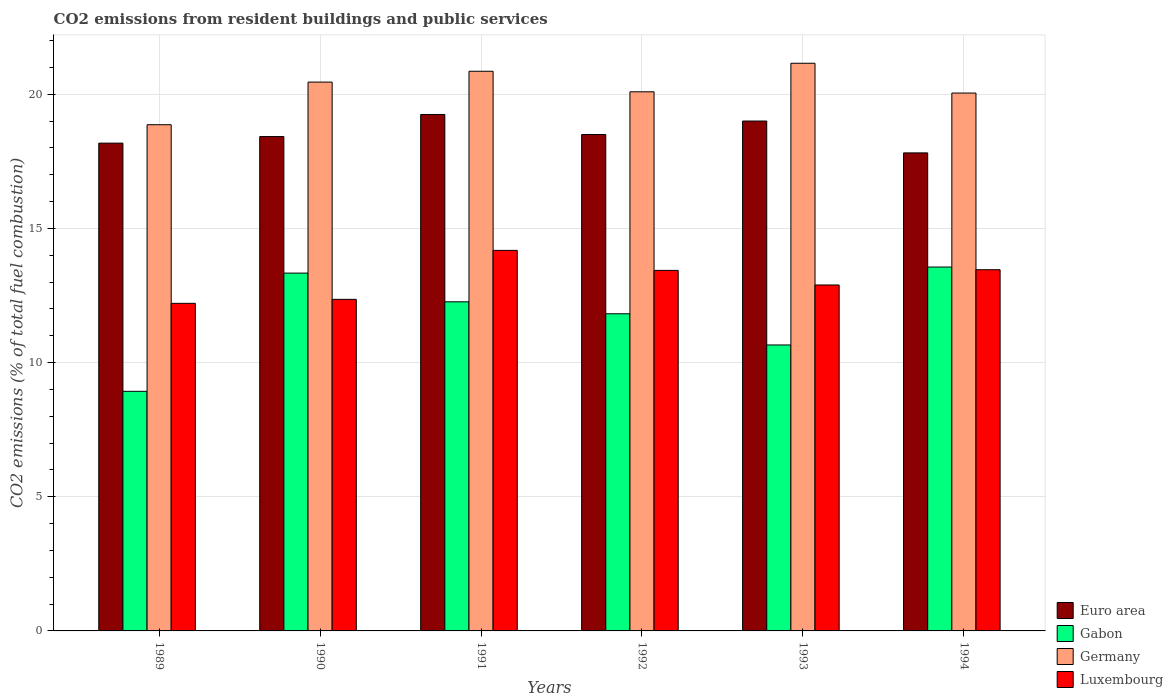Are the number of bars on each tick of the X-axis equal?
Ensure brevity in your answer.  Yes. How many bars are there on the 3rd tick from the left?
Offer a terse response. 4. What is the label of the 6th group of bars from the left?
Provide a short and direct response. 1994. In how many cases, is the number of bars for a given year not equal to the number of legend labels?
Your response must be concise. 0. What is the total CO2 emitted in Germany in 1992?
Your answer should be compact. 20.09. Across all years, what is the maximum total CO2 emitted in Euro area?
Give a very brief answer. 19.24. Across all years, what is the minimum total CO2 emitted in Euro area?
Make the answer very short. 17.81. In which year was the total CO2 emitted in Germany minimum?
Provide a succinct answer. 1989. What is the total total CO2 emitted in Germany in the graph?
Make the answer very short. 121.45. What is the difference between the total CO2 emitted in Germany in 1990 and that in 1994?
Give a very brief answer. 0.41. What is the difference between the total CO2 emitted in Euro area in 1989 and the total CO2 emitted in Germany in 1991?
Ensure brevity in your answer.  -2.68. What is the average total CO2 emitted in Gabon per year?
Keep it short and to the point. 11.76. In the year 1993, what is the difference between the total CO2 emitted in Luxembourg and total CO2 emitted in Gabon?
Keep it short and to the point. 2.24. In how many years, is the total CO2 emitted in Gabon greater than 18?
Ensure brevity in your answer.  0. What is the ratio of the total CO2 emitted in Germany in 1990 to that in 1993?
Your response must be concise. 0.97. Is the difference between the total CO2 emitted in Luxembourg in 1991 and 1992 greater than the difference between the total CO2 emitted in Gabon in 1991 and 1992?
Your answer should be compact. Yes. What is the difference between the highest and the second highest total CO2 emitted in Luxembourg?
Your answer should be compact. 0.72. What is the difference between the highest and the lowest total CO2 emitted in Euro area?
Your answer should be very brief. 1.43. Is the sum of the total CO2 emitted in Germany in 1992 and 1993 greater than the maximum total CO2 emitted in Euro area across all years?
Offer a very short reply. Yes. What does the 2nd bar from the left in 1991 represents?
Your response must be concise. Gabon. What does the 2nd bar from the right in 1990 represents?
Ensure brevity in your answer.  Germany. Is it the case that in every year, the sum of the total CO2 emitted in Germany and total CO2 emitted in Euro area is greater than the total CO2 emitted in Luxembourg?
Offer a very short reply. Yes. Are all the bars in the graph horizontal?
Keep it short and to the point. No. How many years are there in the graph?
Make the answer very short. 6. What is the difference between two consecutive major ticks on the Y-axis?
Make the answer very short. 5. Are the values on the major ticks of Y-axis written in scientific E-notation?
Provide a short and direct response. No. Where does the legend appear in the graph?
Your response must be concise. Bottom right. What is the title of the graph?
Offer a terse response. CO2 emissions from resident buildings and public services. What is the label or title of the X-axis?
Your answer should be very brief. Years. What is the label or title of the Y-axis?
Provide a succinct answer. CO2 emissions (% of total fuel combustion). What is the CO2 emissions (% of total fuel combustion) in Euro area in 1989?
Make the answer very short. 18.18. What is the CO2 emissions (% of total fuel combustion) of Gabon in 1989?
Offer a terse response. 8.93. What is the CO2 emissions (% of total fuel combustion) in Germany in 1989?
Your response must be concise. 18.86. What is the CO2 emissions (% of total fuel combustion) of Luxembourg in 1989?
Ensure brevity in your answer.  12.21. What is the CO2 emissions (% of total fuel combustion) in Euro area in 1990?
Give a very brief answer. 18.42. What is the CO2 emissions (% of total fuel combustion) in Gabon in 1990?
Offer a very short reply. 13.33. What is the CO2 emissions (% of total fuel combustion) of Germany in 1990?
Provide a short and direct response. 20.45. What is the CO2 emissions (% of total fuel combustion) of Luxembourg in 1990?
Keep it short and to the point. 12.36. What is the CO2 emissions (% of total fuel combustion) of Euro area in 1991?
Offer a terse response. 19.24. What is the CO2 emissions (% of total fuel combustion) of Gabon in 1991?
Provide a short and direct response. 12.26. What is the CO2 emissions (% of total fuel combustion) of Germany in 1991?
Ensure brevity in your answer.  20.85. What is the CO2 emissions (% of total fuel combustion) of Luxembourg in 1991?
Offer a very short reply. 14.18. What is the CO2 emissions (% of total fuel combustion) of Euro area in 1992?
Offer a terse response. 18.5. What is the CO2 emissions (% of total fuel combustion) of Gabon in 1992?
Give a very brief answer. 11.82. What is the CO2 emissions (% of total fuel combustion) of Germany in 1992?
Your answer should be compact. 20.09. What is the CO2 emissions (% of total fuel combustion) in Luxembourg in 1992?
Your answer should be compact. 13.43. What is the CO2 emissions (% of total fuel combustion) of Euro area in 1993?
Your answer should be very brief. 19. What is the CO2 emissions (% of total fuel combustion) in Gabon in 1993?
Your answer should be compact. 10.66. What is the CO2 emissions (% of total fuel combustion) of Germany in 1993?
Provide a succinct answer. 21.15. What is the CO2 emissions (% of total fuel combustion) in Luxembourg in 1993?
Provide a succinct answer. 12.89. What is the CO2 emissions (% of total fuel combustion) in Euro area in 1994?
Your answer should be compact. 17.81. What is the CO2 emissions (% of total fuel combustion) in Gabon in 1994?
Give a very brief answer. 13.56. What is the CO2 emissions (% of total fuel combustion) in Germany in 1994?
Provide a short and direct response. 20.04. What is the CO2 emissions (% of total fuel combustion) in Luxembourg in 1994?
Your answer should be very brief. 13.46. Across all years, what is the maximum CO2 emissions (% of total fuel combustion) in Euro area?
Provide a short and direct response. 19.24. Across all years, what is the maximum CO2 emissions (% of total fuel combustion) in Gabon?
Make the answer very short. 13.56. Across all years, what is the maximum CO2 emissions (% of total fuel combustion) in Germany?
Make the answer very short. 21.15. Across all years, what is the maximum CO2 emissions (% of total fuel combustion) in Luxembourg?
Provide a short and direct response. 14.18. Across all years, what is the minimum CO2 emissions (% of total fuel combustion) of Euro area?
Keep it short and to the point. 17.81. Across all years, what is the minimum CO2 emissions (% of total fuel combustion) of Gabon?
Provide a short and direct response. 8.93. Across all years, what is the minimum CO2 emissions (% of total fuel combustion) of Germany?
Give a very brief answer. 18.86. Across all years, what is the minimum CO2 emissions (% of total fuel combustion) in Luxembourg?
Keep it short and to the point. 12.21. What is the total CO2 emissions (% of total fuel combustion) in Euro area in the graph?
Provide a succinct answer. 111.15. What is the total CO2 emissions (% of total fuel combustion) in Gabon in the graph?
Offer a terse response. 70.56. What is the total CO2 emissions (% of total fuel combustion) of Germany in the graph?
Offer a terse response. 121.45. What is the total CO2 emissions (% of total fuel combustion) in Luxembourg in the graph?
Your answer should be very brief. 78.53. What is the difference between the CO2 emissions (% of total fuel combustion) of Euro area in 1989 and that in 1990?
Provide a succinct answer. -0.24. What is the difference between the CO2 emissions (% of total fuel combustion) of Gabon in 1989 and that in 1990?
Provide a succinct answer. -4.4. What is the difference between the CO2 emissions (% of total fuel combustion) in Germany in 1989 and that in 1990?
Your answer should be very brief. -1.59. What is the difference between the CO2 emissions (% of total fuel combustion) of Luxembourg in 1989 and that in 1990?
Give a very brief answer. -0.15. What is the difference between the CO2 emissions (% of total fuel combustion) of Euro area in 1989 and that in 1991?
Ensure brevity in your answer.  -1.07. What is the difference between the CO2 emissions (% of total fuel combustion) in Gabon in 1989 and that in 1991?
Your response must be concise. -3.34. What is the difference between the CO2 emissions (% of total fuel combustion) in Germany in 1989 and that in 1991?
Offer a terse response. -1.99. What is the difference between the CO2 emissions (% of total fuel combustion) of Luxembourg in 1989 and that in 1991?
Your answer should be very brief. -1.97. What is the difference between the CO2 emissions (% of total fuel combustion) in Euro area in 1989 and that in 1992?
Offer a terse response. -0.32. What is the difference between the CO2 emissions (% of total fuel combustion) of Gabon in 1989 and that in 1992?
Your answer should be very brief. -2.89. What is the difference between the CO2 emissions (% of total fuel combustion) of Germany in 1989 and that in 1992?
Provide a succinct answer. -1.23. What is the difference between the CO2 emissions (% of total fuel combustion) of Luxembourg in 1989 and that in 1992?
Give a very brief answer. -1.23. What is the difference between the CO2 emissions (% of total fuel combustion) of Euro area in 1989 and that in 1993?
Offer a very short reply. -0.82. What is the difference between the CO2 emissions (% of total fuel combustion) of Gabon in 1989 and that in 1993?
Your response must be concise. -1.73. What is the difference between the CO2 emissions (% of total fuel combustion) of Germany in 1989 and that in 1993?
Provide a short and direct response. -2.29. What is the difference between the CO2 emissions (% of total fuel combustion) of Luxembourg in 1989 and that in 1993?
Make the answer very short. -0.68. What is the difference between the CO2 emissions (% of total fuel combustion) of Euro area in 1989 and that in 1994?
Keep it short and to the point. 0.36. What is the difference between the CO2 emissions (% of total fuel combustion) in Gabon in 1989 and that in 1994?
Your answer should be very brief. -4.63. What is the difference between the CO2 emissions (% of total fuel combustion) in Germany in 1989 and that in 1994?
Your answer should be compact. -1.18. What is the difference between the CO2 emissions (% of total fuel combustion) of Luxembourg in 1989 and that in 1994?
Provide a succinct answer. -1.25. What is the difference between the CO2 emissions (% of total fuel combustion) in Euro area in 1990 and that in 1991?
Your answer should be compact. -0.82. What is the difference between the CO2 emissions (% of total fuel combustion) in Gabon in 1990 and that in 1991?
Your answer should be very brief. 1.07. What is the difference between the CO2 emissions (% of total fuel combustion) of Germany in 1990 and that in 1991?
Your answer should be compact. -0.4. What is the difference between the CO2 emissions (% of total fuel combustion) of Luxembourg in 1990 and that in 1991?
Your answer should be very brief. -1.83. What is the difference between the CO2 emissions (% of total fuel combustion) of Euro area in 1990 and that in 1992?
Offer a terse response. -0.08. What is the difference between the CO2 emissions (% of total fuel combustion) of Gabon in 1990 and that in 1992?
Keep it short and to the point. 1.52. What is the difference between the CO2 emissions (% of total fuel combustion) in Germany in 1990 and that in 1992?
Offer a terse response. 0.36. What is the difference between the CO2 emissions (% of total fuel combustion) in Luxembourg in 1990 and that in 1992?
Offer a very short reply. -1.08. What is the difference between the CO2 emissions (% of total fuel combustion) in Euro area in 1990 and that in 1993?
Offer a very short reply. -0.58. What is the difference between the CO2 emissions (% of total fuel combustion) in Gabon in 1990 and that in 1993?
Provide a succinct answer. 2.68. What is the difference between the CO2 emissions (% of total fuel combustion) of Germany in 1990 and that in 1993?
Ensure brevity in your answer.  -0.7. What is the difference between the CO2 emissions (% of total fuel combustion) in Luxembourg in 1990 and that in 1993?
Make the answer very short. -0.54. What is the difference between the CO2 emissions (% of total fuel combustion) in Euro area in 1990 and that in 1994?
Provide a succinct answer. 0.61. What is the difference between the CO2 emissions (% of total fuel combustion) in Gabon in 1990 and that in 1994?
Your answer should be compact. -0.23. What is the difference between the CO2 emissions (% of total fuel combustion) of Germany in 1990 and that in 1994?
Your response must be concise. 0.41. What is the difference between the CO2 emissions (% of total fuel combustion) in Luxembourg in 1990 and that in 1994?
Provide a succinct answer. -1.1. What is the difference between the CO2 emissions (% of total fuel combustion) in Euro area in 1991 and that in 1992?
Give a very brief answer. 0.75. What is the difference between the CO2 emissions (% of total fuel combustion) in Gabon in 1991 and that in 1992?
Offer a terse response. 0.45. What is the difference between the CO2 emissions (% of total fuel combustion) of Germany in 1991 and that in 1992?
Your response must be concise. 0.77. What is the difference between the CO2 emissions (% of total fuel combustion) of Luxembourg in 1991 and that in 1992?
Your answer should be very brief. 0.75. What is the difference between the CO2 emissions (% of total fuel combustion) in Euro area in 1991 and that in 1993?
Your answer should be compact. 0.24. What is the difference between the CO2 emissions (% of total fuel combustion) of Gabon in 1991 and that in 1993?
Ensure brevity in your answer.  1.61. What is the difference between the CO2 emissions (% of total fuel combustion) of Germany in 1991 and that in 1993?
Provide a short and direct response. -0.3. What is the difference between the CO2 emissions (% of total fuel combustion) in Luxembourg in 1991 and that in 1993?
Your response must be concise. 1.29. What is the difference between the CO2 emissions (% of total fuel combustion) of Euro area in 1991 and that in 1994?
Your answer should be very brief. 1.43. What is the difference between the CO2 emissions (% of total fuel combustion) of Gabon in 1991 and that in 1994?
Ensure brevity in your answer.  -1.3. What is the difference between the CO2 emissions (% of total fuel combustion) in Germany in 1991 and that in 1994?
Make the answer very short. 0.81. What is the difference between the CO2 emissions (% of total fuel combustion) of Luxembourg in 1991 and that in 1994?
Keep it short and to the point. 0.72. What is the difference between the CO2 emissions (% of total fuel combustion) in Euro area in 1992 and that in 1993?
Offer a very short reply. -0.5. What is the difference between the CO2 emissions (% of total fuel combustion) of Gabon in 1992 and that in 1993?
Provide a short and direct response. 1.16. What is the difference between the CO2 emissions (% of total fuel combustion) of Germany in 1992 and that in 1993?
Your response must be concise. -1.06. What is the difference between the CO2 emissions (% of total fuel combustion) of Luxembourg in 1992 and that in 1993?
Offer a terse response. 0.54. What is the difference between the CO2 emissions (% of total fuel combustion) of Euro area in 1992 and that in 1994?
Provide a short and direct response. 0.68. What is the difference between the CO2 emissions (% of total fuel combustion) of Gabon in 1992 and that in 1994?
Your answer should be very brief. -1.74. What is the difference between the CO2 emissions (% of total fuel combustion) of Germany in 1992 and that in 1994?
Provide a short and direct response. 0.05. What is the difference between the CO2 emissions (% of total fuel combustion) of Luxembourg in 1992 and that in 1994?
Ensure brevity in your answer.  -0.03. What is the difference between the CO2 emissions (% of total fuel combustion) of Euro area in 1993 and that in 1994?
Give a very brief answer. 1.19. What is the difference between the CO2 emissions (% of total fuel combustion) in Gabon in 1993 and that in 1994?
Provide a short and direct response. -2.9. What is the difference between the CO2 emissions (% of total fuel combustion) in Germany in 1993 and that in 1994?
Your answer should be compact. 1.11. What is the difference between the CO2 emissions (% of total fuel combustion) in Luxembourg in 1993 and that in 1994?
Your answer should be very brief. -0.57. What is the difference between the CO2 emissions (% of total fuel combustion) of Euro area in 1989 and the CO2 emissions (% of total fuel combustion) of Gabon in 1990?
Offer a very short reply. 4.84. What is the difference between the CO2 emissions (% of total fuel combustion) in Euro area in 1989 and the CO2 emissions (% of total fuel combustion) in Germany in 1990?
Make the answer very short. -2.27. What is the difference between the CO2 emissions (% of total fuel combustion) of Euro area in 1989 and the CO2 emissions (% of total fuel combustion) of Luxembourg in 1990?
Ensure brevity in your answer.  5.82. What is the difference between the CO2 emissions (% of total fuel combustion) of Gabon in 1989 and the CO2 emissions (% of total fuel combustion) of Germany in 1990?
Keep it short and to the point. -11.52. What is the difference between the CO2 emissions (% of total fuel combustion) of Gabon in 1989 and the CO2 emissions (% of total fuel combustion) of Luxembourg in 1990?
Make the answer very short. -3.43. What is the difference between the CO2 emissions (% of total fuel combustion) of Germany in 1989 and the CO2 emissions (% of total fuel combustion) of Luxembourg in 1990?
Provide a short and direct response. 6.51. What is the difference between the CO2 emissions (% of total fuel combustion) in Euro area in 1989 and the CO2 emissions (% of total fuel combustion) in Gabon in 1991?
Provide a succinct answer. 5.91. What is the difference between the CO2 emissions (% of total fuel combustion) in Euro area in 1989 and the CO2 emissions (% of total fuel combustion) in Germany in 1991?
Offer a terse response. -2.68. What is the difference between the CO2 emissions (% of total fuel combustion) in Euro area in 1989 and the CO2 emissions (% of total fuel combustion) in Luxembourg in 1991?
Provide a succinct answer. 4. What is the difference between the CO2 emissions (% of total fuel combustion) of Gabon in 1989 and the CO2 emissions (% of total fuel combustion) of Germany in 1991?
Your answer should be compact. -11.93. What is the difference between the CO2 emissions (% of total fuel combustion) in Gabon in 1989 and the CO2 emissions (% of total fuel combustion) in Luxembourg in 1991?
Keep it short and to the point. -5.25. What is the difference between the CO2 emissions (% of total fuel combustion) in Germany in 1989 and the CO2 emissions (% of total fuel combustion) in Luxembourg in 1991?
Your response must be concise. 4.68. What is the difference between the CO2 emissions (% of total fuel combustion) of Euro area in 1989 and the CO2 emissions (% of total fuel combustion) of Gabon in 1992?
Offer a very short reply. 6.36. What is the difference between the CO2 emissions (% of total fuel combustion) in Euro area in 1989 and the CO2 emissions (% of total fuel combustion) in Germany in 1992?
Make the answer very short. -1.91. What is the difference between the CO2 emissions (% of total fuel combustion) of Euro area in 1989 and the CO2 emissions (% of total fuel combustion) of Luxembourg in 1992?
Keep it short and to the point. 4.74. What is the difference between the CO2 emissions (% of total fuel combustion) of Gabon in 1989 and the CO2 emissions (% of total fuel combustion) of Germany in 1992?
Ensure brevity in your answer.  -11.16. What is the difference between the CO2 emissions (% of total fuel combustion) of Gabon in 1989 and the CO2 emissions (% of total fuel combustion) of Luxembourg in 1992?
Provide a succinct answer. -4.51. What is the difference between the CO2 emissions (% of total fuel combustion) in Germany in 1989 and the CO2 emissions (% of total fuel combustion) in Luxembourg in 1992?
Provide a short and direct response. 5.43. What is the difference between the CO2 emissions (% of total fuel combustion) in Euro area in 1989 and the CO2 emissions (% of total fuel combustion) in Gabon in 1993?
Ensure brevity in your answer.  7.52. What is the difference between the CO2 emissions (% of total fuel combustion) in Euro area in 1989 and the CO2 emissions (% of total fuel combustion) in Germany in 1993?
Your answer should be compact. -2.98. What is the difference between the CO2 emissions (% of total fuel combustion) in Euro area in 1989 and the CO2 emissions (% of total fuel combustion) in Luxembourg in 1993?
Make the answer very short. 5.29. What is the difference between the CO2 emissions (% of total fuel combustion) in Gabon in 1989 and the CO2 emissions (% of total fuel combustion) in Germany in 1993?
Provide a short and direct response. -12.22. What is the difference between the CO2 emissions (% of total fuel combustion) of Gabon in 1989 and the CO2 emissions (% of total fuel combustion) of Luxembourg in 1993?
Your answer should be compact. -3.96. What is the difference between the CO2 emissions (% of total fuel combustion) of Germany in 1989 and the CO2 emissions (% of total fuel combustion) of Luxembourg in 1993?
Keep it short and to the point. 5.97. What is the difference between the CO2 emissions (% of total fuel combustion) of Euro area in 1989 and the CO2 emissions (% of total fuel combustion) of Gabon in 1994?
Offer a very short reply. 4.62. What is the difference between the CO2 emissions (% of total fuel combustion) in Euro area in 1989 and the CO2 emissions (% of total fuel combustion) in Germany in 1994?
Provide a succinct answer. -1.87. What is the difference between the CO2 emissions (% of total fuel combustion) in Euro area in 1989 and the CO2 emissions (% of total fuel combustion) in Luxembourg in 1994?
Your answer should be compact. 4.72. What is the difference between the CO2 emissions (% of total fuel combustion) in Gabon in 1989 and the CO2 emissions (% of total fuel combustion) in Germany in 1994?
Make the answer very short. -11.11. What is the difference between the CO2 emissions (% of total fuel combustion) of Gabon in 1989 and the CO2 emissions (% of total fuel combustion) of Luxembourg in 1994?
Your response must be concise. -4.53. What is the difference between the CO2 emissions (% of total fuel combustion) in Germany in 1989 and the CO2 emissions (% of total fuel combustion) in Luxembourg in 1994?
Your answer should be compact. 5.4. What is the difference between the CO2 emissions (% of total fuel combustion) of Euro area in 1990 and the CO2 emissions (% of total fuel combustion) of Gabon in 1991?
Your answer should be compact. 6.16. What is the difference between the CO2 emissions (% of total fuel combustion) of Euro area in 1990 and the CO2 emissions (% of total fuel combustion) of Germany in 1991?
Your answer should be compact. -2.43. What is the difference between the CO2 emissions (% of total fuel combustion) in Euro area in 1990 and the CO2 emissions (% of total fuel combustion) in Luxembourg in 1991?
Your response must be concise. 4.24. What is the difference between the CO2 emissions (% of total fuel combustion) in Gabon in 1990 and the CO2 emissions (% of total fuel combustion) in Germany in 1991?
Make the answer very short. -7.52. What is the difference between the CO2 emissions (% of total fuel combustion) of Gabon in 1990 and the CO2 emissions (% of total fuel combustion) of Luxembourg in 1991?
Make the answer very short. -0.85. What is the difference between the CO2 emissions (% of total fuel combustion) of Germany in 1990 and the CO2 emissions (% of total fuel combustion) of Luxembourg in 1991?
Your response must be concise. 6.27. What is the difference between the CO2 emissions (% of total fuel combustion) of Euro area in 1990 and the CO2 emissions (% of total fuel combustion) of Gabon in 1992?
Provide a succinct answer. 6.6. What is the difference between the CO2 emissions (% of total fuel combustion) of Euro area in 1990 and the CO2 emissions (% of total fuel combustion) of Germany in 1992?
Your answer should be very brief. -1.67. What is the difference between the CO2 emissions (% of total fuel combustion) of Euro area in 1990 and the CO2 emissions (% of total fuel combustion) of Luxembourg in 1992?
Give a very brief answer. 4.99. What is the difference between the CO2 emissions (% of total fuel combustion) of Gabon in 1990 and the CO2 emissions (% of total fuel combustion) of Germany in 1992?
Ensure brevity in your answer.  -6.76. What is the difference between the CO2 emissions (% of total fuel combustion) in Gabon in 1990 and the CO2 emissions (% of total fuel combustion) in Luxembourg in 1992?
Keep it short and to the point. -0.1. What is the difference between the CO2 emissions (% of total fuel combustion) of Germany in 1990 and the CO2 emissions (% of total fuel combustion) of Luxembourg in 1992?
Ensure brevity in your answer.  7.02. What is the difference between the CO2 emissions (% of total fuel combustion) of Euro area in 1990 and the CO2 emissions (% of total fuel combustion) of Gabon in 1993?
Provide a succinct answer. 7.77. What is the difference between the CO2 emissions (% of total fuel combustion) in Euro area in 1990 and the CO2 emissions (% of total fuel combustion) in Germany in 1993?
Make the answer very short. -2.73. What is the difference between the CO2 emissions (% of total fuel combustion) of Euro area in 1990 and the CO2 emissions (% of total fuel combustion) of Luxembourg in 1993?
Your response must be concise. 5.53. What is the difference between the CO2 emissions (% of total fuel combustion) in Gabon in 1990 and the CO2 emissions (% of total fuel combustion) in Germany in 1993?
Provide a succinct answer. -7.82. What is the difference between the CO2 emissions (% of total fuel combustion) in Gabon in 1990 and the CO2 emissions (% of total fuel combustion) in Luxembourg in 1993?
Your response must be concise. 0.44. What is the difference between the CO2 emissions (% of total fuel combustion) in Germany in 1990 and the CO2 emissions (% of total fuel combustion) in Luxembourg in 1993?
Keep it short and to the point. 7.56. What is the difference between the CO2 emissions (% of total fuel combustion) in Euro area in 1990 and the CO2 emissions (% of total fuel combustion) in Gabon in 1994?
Your response must be concise. 4.86. What is the difference between the CO2 emissions (% of total fuel combustion) in Euro area in 1990 and the CO2 emissions (% of total fuel combustion) in Germany in 1994?
Provide a short and direct response. -1.62. What is the difference between the CO2 emissions (% of total fuel combustion) of Euro area in 1990 and the CO2 emissions (% of total fuel combustion) of Luxembourg in 1994?
Your answer should be very brief. 4.96. What is the difference between the CO2 emissions (% of total fuel combustion) in Gabon in 1990 and the CO2 emissions (% of total fuel combustion) in Germany in 1994?
Your answer should be compact. -6.71. What is the difference between the CO2 emissions (% of total fuel combustion) in Gabon in 1990 and the CO2 emissions (% of total fuel combustion) in Luxembourg in 1994?
Your response must be concise. -0.13. What is the difference between the CO2 emissions (% of total fuel combustion) of Germany in 1990 and the CO2 emissions (% of total fuel combustion) of Luxembourg in 1994?
Your answer should be compact. 6.99. What is the difference between the CO2 emissions (% of total fuel combustion) of Euro area in 1991 and the CO2 emissions (% of total fuel combustion) of Gabon in 1992?
Provide a succinct answer. 7.43. What is the difference between the CO2 emissions (% of total fuel combustion) of Euro area in 1991 and the CO2 emissions (% of total fuel combustion) of Germany in 1992?
Provide a succinct answer. -0.85. What is the difference between the CO2 emissions (% of total fuel combustion) in Euro area in 1991 and the CO2 emissions (% of total fuel combustion) in Luxembourg in 1992?
Give a very brief answer. 5.81. What is the difference between the CO2 emissions (% of total fuel combustion) in Gabon in 1991 and the CO2 emissions (% of total fuel combustion) in Germany in 1992?
Your response must be concise. -7.83. What is the difference between the CO2 emissions (% of total fuel combustion) in Gabon in 1991 and the CO2 emissions (% of total fuel combustion) in Luxembourg in 1992?
Make the answer very short. -1.17. What is the difference between the CO2 emissions (% of total fuel combustion) of Germany in 1991 and the CO2 emissions (% of total fuel combustion) of Luxembourg in 1992?
Offer a very short reply. 7.42. What is the difference between the CO2 emissions (% of total fuel combustion) in Euro area in 1991 and the CO2 emissions (% of total fuel combustion) in Gabon in 1993?
Your answer should be very brief. 8.59. What is the difference between the CO2 emissions (% of total fuel combustion) of Euro area in 1991 and the CO2 emissions (% of total fuel combustion) of Germany in 1993?
Give a very brief answer. -1.91. What is the difference between the CO2 emissions (% of total fuel combustion) in Euro area in 1991 and the CO2 emissions (% of total fuel combustion) in Luxembourg in 1993?
Your response must be concise. 6.35. What is the difference between the CO2 emissions (% of total fuel combustion) of Gabon in 1991 and the CO2 emissions (% of total fuel combustion) of Germany in 1993?
Your response must be concise. -8.89. What is the difference between the CO2 emissions (% of total fuel combustion) of Gabon in 1991 and the CO2 emissions (% of total fuel combustion) of Luxembourg in 1993?
Provide a succinct answer. -0.63. What is the difference between the CO2 emissions (% of total fuel combustion) in Germany in 1991 and the CO2 emissions (% of total fuel combustion) in Luxembourg in 1993?
Provide a short and direct response. 7.96. What is the difference between the CO2 emissions (% of total fuel combustion) of Euro area in 1991 and the CO2 emissions (% of total fuel combustion) of Gabon in 1994?
Ensure brevity in your answer.  5.69. What is the difference between the CO2 emissions (% of total fuel combustion) in Euro area in 1991 and the CO2 emissions (% of total fuel combustion) in Germany in 1994?
Make the answer very short. -0.8. What is the difference between the CO2 emissions (% of total fuel combustion) of Euro area in 1991 and the CO2 emissions (% of total fuel combustion) of Luxembourg in 1994?
Provide a succinct answer. 5.78. What is the difference between the CO2 emissions (% of total fuel combustion) in Gabon in 1991 and the CO2 emissions (% of total fuel combustion) in Germany in 1994?
Provide a short and direct response. -7.78. What is the difference between the CO2 emissions (% of total fuel combustion) of Gabon in 1991 and the CO2 emissions (% of total fuel combustion) of Luxembourg in 1994?
Provide a succinct answer. -1.2. What is the difference between the CO2 emissions (% of total fuel combustion) in Germany in 1991 and the CO2 emissions (% of total fuel combustion) in Luxembourg in 1994?
Give a very brief answer. 7.4. What is the difference between the CO2 emissions (% of total fuel combustion) in Euro area in 1992 and the CO2 emissions (% of total fuel combustion) in Gabon in 1993?
Give a very brief answer. 7.84. What is the difference between the CO2 emissions (% of total fuel combustion) in Euro area in 1992 and the CO2 emissions (% of total fuel combustion) in Germany in 1993?
Offer a very short reply. -2.66. What is the difference between the CO2 emissions (% of total fuel combustion) of Euro area in 1992 and the CO2 emissions (% of total fuel combustion) of Luxembourg in 1993?
Give a very brief answer. 5.61. What is the difference between the CO2 emissions (% of total fuel combustion) of Gabon in 1992 and the CO2 emissions (% of total fuel combustion) of Germany in 1993?
Your answer should be compact. -9.33. What is the difference between the CO2 emissions (% of total fuel combustion) in Gabon in 1992 and the CO2 emissions (% of total fuel combustion) in Luxembourg in 1993?
Your response must be concise. -1.07. What is the difference between the CO2 emissions (% of total fuel combustion) of Germany in 1992 and the CO2 emissions (% of total fuel combustion) of Luxembourg in 1993?
Give a very brief answer. 7.2. What is the difference between the CO2 emissions (% of total fuel combustion) of Euro area in 1992 and the CO2 emissions (% of total fuel combustion) of Gabon in 1994?
Your answer should be very brief. 4.94. What is the difference between the CO2 emissions (% of total fuel combustion) of Euro area in 1992 and the CO2 emissions (% of total fuel combustion) of Germany in 1994?
Give a very brief answer. -1.55. What is the difference between the CO2 emissions (% of total fuel combustion) in Euro area in 1992 and the CO2 emissions (% of total fuel combustion) in Luxembourg in 1994?
Offer a terse response. 5.04. What is the difference between the CO2 emissions (% of total fuel combustion) of Gabon in 1992 and the CO2 emissions (% of total fuel combustion) of Germany in 1994?
Your answer should be very brief. -8.22. What is the difference between the CO2 emissions (% of total fuel combustion) in Gabon in 1992 and the CO2 emissions (% of total fuel combustion) in Luxembourg in 1994?
Keep it short and to the point. -1.64. What is the difference between the CO2 emissions (% of total fuel combustion) of Germany in 1992 and the CO2 emissions (% of total fuel combustion) of Luxembourg in 1994?
Offer a terse response. 6.63. What is the difference between the CO2 emissions (% of total fuel combustion) of Euro area in 1993 and the CO2 emissions (% of total fuel combustion) of Gabon in 1994?
Provide a succinct answer. 5.44. What is the difference between the CO2 emissions (% of total fuel combustion) in Euro area in 1993 and the CO2 emissions (% of total fuel combustion) in Germany in 1994?
Keep it short and to the point. -1.04. What is the difference between the CO2 emissions (% of total fuel combustion) in Euro area in 1993 and the CO2 emissions (% of total fuel combustion) in Luxembourg in 1994?
Ensure brevity in your answer.  5.54. What is the difference between the CO2 emissions (% of total fuel combustion) in Gabon in 1993 and the CO2 emissions (% of total fuel combustion) in Germany in 1994?
Ensure brevity in your answer.  -9.39. What is the difference between the CO2 emissions (% of total fuel combustion) in Gabon in 1993 and the CO2 emissions (% of total fuel combustion) in Luxembourg in 1994?
Offer a terse response. -2.8. What is the difference between the CO2 emissions (% of total fuel combustion) of Germany in 1993 and the CO2 emissions (% of total fuel combustion) of Luxembourg in 1994?
Your answer should be compact. 7.69. What is the average CO2 emissions (% of total fuel combustion) of Euro area per year?
Provide a short and direct response. 18.53. What is the average CO2 emissions (% of total fuel combustion) of Gabon per year?
Offer a terse response. 11.76. What is the average CO2 emissions (% of total fuel combustion) in Germany per year?
Provide a short and direct response. 20.24. What is the average CO2 emissions (% of total fuel combustion) of Luxembourg per year?
Keep it short and to the point. 13.09. In the year 1989, what is the difference between the CO2 emissions (% of total fuel combustion) in Euro area and CO2 emissions (% of total fuel combustion) in Gabon?
Give a very brief answer. 9.25. In the year 1989, what is the difference between the CO2 emissions (% of total fuel combustion) of Euro area and CO2 emissions (% of total fuel combustion) of Germany?
Ensure brevity in your answer.  -0.69. In the year 1989, what is the difference between the CO2 emissions (% of total fuel combustion) in Euro area and CO2 emissions (% of total fuel combustion) in Luxembourg?
Provide a short and direct response. 5.97. In the year 1989, what is the difference between the CO2 emissions (% of total fuel combustion) of Gabon and CO2 emissions (% of total fuel combustion) of Germany?
Provide a short and direct response. -9.93. In the year 1989, what is the difference between the CO2 emissions (% of total fuel combustion) in Gabon and CO2 emissions (% of total fuel combustion) in Luxembourg?
Provide a short and direct response. -3.28. In the year 1989, what is the difference between the CO2 emissions (% of total fuel combustion) of Germany and CO2 emissions (% of total fuel combustion) of Luxembourg?
Give a very brief answer. 6.66. In the year 1990, what is the difference between the CO2 emissions (% of total fuel combustion) of Euro area and CO2 emissions (% of total fuel combustion) of Gabon?
Provide a succinct answer. 5.09. In the year 1990, what is the difference between the CO2 emissions (% of total fuel combustion) of Euro area and CO2 emissions (% of total fuel combustion) of Germany?
Offer a terse response. -2.03. In the year 1990, what is the difference between the CO2 emissions (% of total fuel combustion) in Euro area and CO2 emissions (% of total fuel combustion) in Luxembourg?
Ensure brevity in your answer.  6.07. In the year 1990, what is the difference between the CO2 emissions (% of total fuel combustion) of Gabon and CO2 emissions (% of total fuel combustion) of Germany?
Keep it short and to the point. -7.12. In the year 1990, what is the difference between the CO2 emissions (% of total fuel combustion) of Gabon and CO2 emissions (% of total fuel combustion) of Luxembourg?
Make the answer very short. 0.98. In the year 1990, what is the difference between the CO2 emissions (% of total fuel combustion) of Germany and CO2 emissions (% of total fuel combustion) of Luxembourg?
Offer a terse response. 8.1. In the year 1991, what is the difference between the CO2 emissions (% of total fuel combustion) of Euro area and CO2 emissions (% of total fuel combustion) of Gabon?
Give a very brief answer. 6.98. In the year 1991, what is the difference between the CO2 emissions (% of total fuel combustion) in Euro area and CO2 emissions (% of total fuel combustion) in Germany?
Offer a very short reply. -1.61. In the year 1991, what is the difference between the CO2 emissions (% of total fuel combustion) of Euro area and CO2 emissions (% of total fuel combustion) of Luxembourg?
Make the answer very short. 5.06. In the year 1991, what is the difference between the CO2 emissions (% of total fuel combustion) in Gabon and CO2 emissions (% of total fuel combustion) in Germany?
Offer a very short reply. -8.59. In the year 1991, what is the difference between the CO2 emissions (% of total fuel combustion) of Gabon and CO2 emissions (% of total fuel combustion) of Luxembourg?
Provide a short and direct response. -1.92. In the year 1991, what is the difference between the CO2 emissions (% of total fuel combustion) in Germany and CO2 emissions (% of total fuel combustion) in Luxembourg?
Your response must be concise. 6.67. In the year 1992, what is the difference between the CO2 emissions (% of total fuel combustion) of Euro area and CO2 emissions (% of total fuel combustion) of Gabon?
Your answer should be very brief. 6.68. In the year 1992, what is the difference between the CO2 emissions (% of total fuel combustion) in Euro area and CO2 emissions (% of total fuel combustion) in Germany?
Make the answer very short. -1.59. In the year 1992, what is the difference between the CO2 emissions (% of total fuel combustion) of Euro area and CO2 emissions (% of total fuel combustion) of Luxembourg?
Provide a short and direct response. 5.06. In the year 1992, what is the difference between the CO2 emissions (% of total fuel combustion) in Gabon and CO2 emissions (% of total fuel combustion) in Germany?
Offer a terse response. -8.27. In the year 1992, what is the difference between the CO2 emissions (% of total fuel combustion) in Gabon and CO2 emissions (% of total fuel combustion) in Luxembourg?
Offer a very short reply. -1.62. In the year 1992, what is the difference between the CO2 emissions (% of total fuel combustion) in Germany and CO2 emissions (% of total fuel combustion) in Luxembourg?
Make the answer very short. 6.66. In the year 1993, what is the difference between the CO2 emissions (% of total fuel combustion) of Euro area and CO2 emissions (% of total fuel combustion) of Gabon?
Your answer should be compact. 8.34. In the year 1993, what is the difference between the CO2 emissions (% of total fuel combustion) of Euro area and CO2 emissions (% of total fuel combustion) of Germany?
Offer a terse response. -2.15. In the year 1993, what is the difference between the CO2 emissions (% of total fuel combustion) of Euro area and CO2 emissions (% of total fuel combustion) of Luxembourg?
Your answer should be compact. 6.11. In the year 1993, what is the difference between the CO2 emissions (% of total fuel combustion) in Gabon and CO2 emissions (% of total fuel combustion) in Germany?
Provide a short and direct response. -10.5. In the year 1993, what is the difference between the CO2 emissions (% of total fuel combustion) in Gabon and CO2 emissions (% of total fuel combustion) in Luxembourg?
Give a very brief answer. -2.24. In the year 1993, what is the difference between the CO2 emissions (% of total fuel combustion) in Germany and CO2 emissions (% of total fuel combustion) in Luxembourg?
Provide a succinct answer. 8.26. In the year 1994, what is the difference between the CO2 emissions (% of total fuel combustion) of Euro area and CO2 emissions (% of total fuel combustion) of Gabon?
Offer a very short reply. 4.25. In the year 1994, what is the difference between the CO2 emissions (% of total fuel combustion) in Euro area and CO2 emissions (% of total fuel combustion) in Germany?
Provide a succinct answer. -2.23. In the year 1994, what is the difference between the CO2 emissions (% of total fuel combustion) in Euro area and CO2 emissions (% of total fuel combustion) in Luxembourg?
Provide a short and direct response. 4.35. In the year 1994, what is the difference between the CO2 emissions (% of total fuel combustion) of Gabon and CO2 emissions (% of total fuel combustion) of Germany?
Offer a terse response. -6.48. In the year 1994, what is the difference between the CO2 emissions (% of total fuel combustion) in Gabon and CO2 emissions (% of total fuel combustion) in Luxembourg?
Your answer should be very brief. 0.1. In the year 1994, what is the difference between the CO2 emissions (% of total fuel combustion) of Germany and CO2 emissions (% of total fuel combustion) of Luxembourg?
Ensure brevity in your answer.  6.58. What is the ratio of the CO2 emissions (% of total fuel combustion) of Euro area in 1989 to that in 1990?
Make the answer very short. 0.99. What is the ratio of the CO2 emissions (% of total fuel combustion) in Gabon in 1989 to that in 1990?
Your answer should be very brief. 0.67. What is the ratio of the CO2 emissions (% of total fuel combustion) of Germany in 1989 to that in 1990?
Ensure brevity in your answer.  0.92. What is the ratio of the CO2 emissions (% of total fuel combustion) in Luxembourg in 1989 to that in 1990?
Make the answer very short. 0.99. What is the ratio of the CO2 emissions (% of total fuel combustion) of Euro area in 1989 to that in 1991?
Your answer should be very brief. 0.94. What is the ratio of the CO2 emissions (% of total fuel combustion) of Gabon in 1989 to that in 1991?
Give a very brief answer. 0.73. What is the ratio of the CO2 emissions (% of total fuel combustion) of Germany in 1989 to that in 1991?
Ensure brevity in your answer.  0.9. What is the ratio of the CO2 emissions (% of total fuel combustion) in Luxembourg in 1989 to that in 1991?
Your response must be concise. 0.86. What is the ratio of the CO2 emissions (% of total fuel combustion) in Euro area in 1989 to that in 1992?
Provide a short and direct response. 0.98. What is the ratio of the CO2 emissions (% of total fuel combustion) of Gabon in 1989 to that in 1992?
Give a very brief answer. 0.76. What is the ratio of the CO2 emissions (% of total fuel combustion) in Germany in 1989 to that in 1992?
Ensure brevity in your answer.  0.94. What is the ratio of the CO2 emissions (% of total fuel combustion) in Luxembourg in 1989 to that in 1992?
Ensure brevity in your answer.  0.91. What is the ratio of the CO2 emissions (% of total fuel combustion) of Euro area in 1989 to that in 1993?
Give a very brief answer. 0.96. What is the ratio of the CO2 emissions (% of total fuel combustion) of Gabon in 1989 to that in 1993?
Your response must be concise. 0.84. What is the ratio of the CO2 emissions (% of total fuel combustion) of Germany in 1989 to that in 1993?
Your answer should be compact. 0.89. What is the ratio of the CO2 emissions (% of total fuel combustion) of Luxembourg in 1989 to that in 1993?
Your answer should be compact. 0.95. What is the ratio of the CO2 emissions (% of total fuel combustion) of Euro area in 1989 to that in 1994?
Your answer should be compact. 1.02. What is the ratio of the CO2 emissions (% of total fuel combustion) in Gabon in 1989 to that in 1994?
Your answer should be compact. 0.66. What is the ratio of the CO2 emissions (% of total fuel combustion) of Germany in 1989 to that in 1994?
Make the answer very short. 0.94. What is the ratio of the CO2 emissions (% of total fuel combustion) of Luxembourg in 1989 to that in 1994?
Provide a short and direct response. 0.91. What is the ratio of the CO2 emissions (% of total fuel combustion) in Euro area in 1990 to that in 1991?
Offer a very short reply. 0.96. What is the ratio of the CO2 emissions (% of total fuel combustion) of Gabon in 1990 to that in 1991?
Your answer should be very brief. 1.09. What is the ratio of the CO2 emissions (% of total fuel combustion) in Germany in 1990 to that in 1991?
Provide a short and direct response. 0.98. What is the ratio of the CO2 emissions (% of total fuel combustion) in Luxembourg in 1990 to that in 1991?
Provide a succinct answer. 0.87. What is the ratio of the CO2 emissions (% of total fuel combustion) in Euro area in 1990 to that in 1992?
Give a very brief answer. 1. What is the ratio of the CO2 emissions (% of total fuel combustion) of Gabon in 1990 to that in 1992?
Your response must be concise. 1.13. What is the ratio of the CO2 emissions (% of total fuel combustion) of Germany in 1990 to that in 1992?
Keep it short and to the point. 1.02. What is the ratio of the CO2 emissions (% of total fuel combustion) in Luxembourg in 1990 to that in 1992?
Your answer should be very brief. 0.92. What is the ratio of the CO2 emissions (% of total fuel combustion) in Euro area in 1990 to that in 1993?
Your response must be concise. 0.97. What is the ratio of the CO2 emissions (% of total fuel combustion) of Gabon in 1990 to that in 1993?
Make the answer very short. 1.25. What is the ratio of the CO2 emissions (% of total fuel combustion) in Germany in 1990 to that in 1993?
Offer a very short reply. 0.97. What is the ratio of the CO2 emissions (% of total fuel combustion) of Luxembourg in 1990 to that in 1993?
Give a very brief answer. 0.96. What is the ratio of the CO2 emissions (% of total fuel combustion) of Euro area in 1990 to that in 1994?
Your answer should be compact. 1.03. What is the ratio of the CO2 emissions (% of total fuel combustion) in Gabon in 1990 to that in 1994?
Your answer should be very brief. 0.98. What is the ratio of the CO2 emissions (% of total fuel combustion) in Germany in 1990 to that in 1994?
Keep it short and to the point. 1.02. What is the ratio of the CO2 emissions (% of total fuel combustion) of Luxembourg in 1990 to that in 1994?
Offer a terse response. 0.92. What is the ratio of the CO2 emissions (% of total fuel combustion) of Euro area in 1991 to that in 1992?
Make the answer very short. 1.04. What is the ratio of the CO2 emissions (% of total fuel combustion) of Gabon in 1991 to that in 1992?
Offer a terse response. 1.04. What is the ratio of the CO2 emissions (% of total fuel combustion) in Germany in 1991 to that in 1992?
Provide a succinct answer. 1.04. What is the ratio of the CO2 emissions (% of total fuel combustion) of Luxembourg in 1991 to that in 1992?
Offer a terse response. 1.06. What is the ratio of the CO2 emissions (% of total fuel combustion) in Euro area in 1991 to that in 1993?
Make the answer very short. 1.01. What is the ratio of the CO2 emissions (% of total fuel combustion) in Gabon in 1991 to that in 1993?
Your response must be concise. 1.15. What is the ratio of the CO2 emissions (% of total fuel combustion) of Germany in 1991 to that in 1993?
Provide a short and direct response. 0.99. What is the ratio of the CO2 emissions (% of total fuel combustion) of Luxembourg in 1991 to that in 1993?
Give a very brief answer. 1.1. What is the ratio of the CO2 emissions (% of total fuel combustion) in Euro area in 1991 to that in 1994?
Your answer should be compact. 1.08. What is the ratio of the CO2 emissions (% of total fuel combustion) in Gabon in 1991 to that in 1994?
Provide a succinct answer. 0.9. What is the ratio of the CO2 emissions (% of total fuel combustion) of Germany in 1991 to that in 1994?
Provide a succinct answer. 1.04. What is the ratio of the CO2 emissions (% of total fuel combustion) of Luxembourg in 1991 to that in 1994?
Your answer should be very brief. 1.05. What is the ratio of the CO2 emissions (% of total fuel combustion) of Euro area in 1992 to that in 1993?
Keep it short and to the point. 0.97. What is the ratio of the CO2 emissions (% of total fuel combustion) in Gabon in 1992 to that in 1993?
Your response must be concise. 1.11. What is the ratio of the CO2 emissions (% of total fuel combustion) of Germany in 1992 to that in 1993?
Make the answer very short. 0.95. What is the ratio of the CO2 emissions (% of total fuel combustion) in Luxembourg in 1992 to that in 1993?
Keep it short and to the point. 1.04. What is the ratio of the CO2 emissions (% of total fuel combustion) in Euro area in 1992 to that in 1994?
Make the answer very short. 1.04. What is the ratio of the CO2 emissions (% of total fuel combustion) of Gabon in 1992 to that in 1994?
Your answer should be compact. 0.87. What is the ratio of the CO2 emissions (% of total fuel combustion) in Luxembourg in 1992 to that in 1994?
Provide a succinct answer. 1. What is the ratio of the CO2 emissions (% of total fuel combustion) of Euro area in 1993 to that in 1994?
Offer a terse response. 1.07. What is the ratio of the CO2 emissions (% of total fuel combustion) of Gabon in 1993 to that in 1994?
Provide a short and direct response. 0.79. What is the ratio of the CO2 emissions (% of total fuel combustion) in Germany in 1993 to that in 1994?
Provide a succinct answer. 1.06. What is the ratio of the CO2 emissions (% of total fuel combustion) of Luxembourg in 1993 to that in 1994?
Provide a succinct answer. 0.96. What is the difference between the highest and the second highest CO2 emissions (% of total fuel combustion) of Euro area?
Your answer should be very brief. 0.24. What is the difference between the highest and the second highest CO2 emissions (% of total fuel combustion) in Gabon?
Ensure brevity in your answer.  0.23. What is the difference between the highest and the second highest CO2 emissions (% of total fuel combustion) in Germany?
Your answer should be very brief. 0.3. What is the difference between the highest and the second highest CO2 emissions (% of total fuel combustion) of Luxembourg?
Make the answer very short. 0.72. What is the difference between the highest and the lowest CO2 emissions (% of total fuel combustion) in Euro area?
Give a very brief answer. 1.43. What is the difference between the highest and the lowest CO2 emissions (% of total fuel combustion) of Gabon?
Make the answer very short. 4.63. What is the difference between the highest and the lowest CO2 emissions (% of total fuel combustion) in Germany?
Keep it short and to the point. 2.29. What is the difference between the highest and the lowest CO2 emissions (% of total fuel combustion) of Luxembourg?
Your answer should be compact. 1.97. 